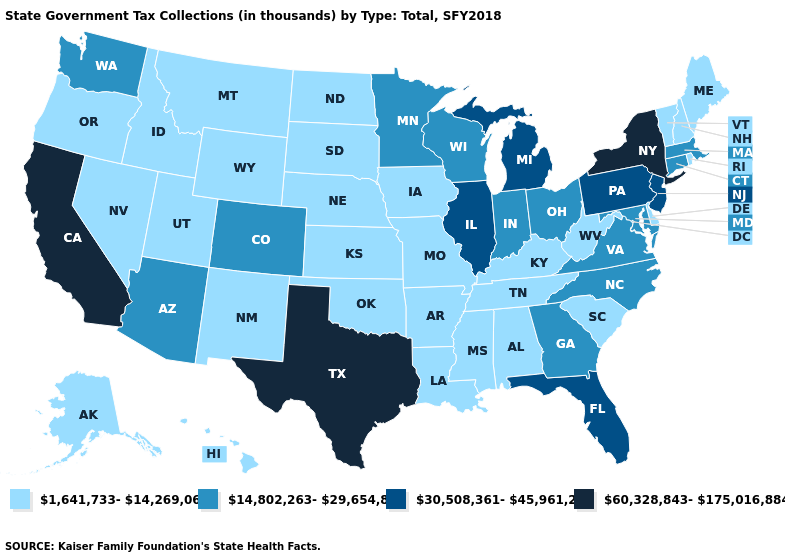Does Texas have the same value as New York?
Write a very short answer. Yes. Name the states that have a value in the range 14,802,263-29,654,803?
Write a very short answer. Arizona, Colorado, Connecticut, Georgia, Indiana, Maryland, Massachusetts, Minnesota, North Carolina, Ohio, Virginia, Washington, Wisconsin. Does Wisconsin have a lower value than Florida?
Concise answer only. Yes. Which states have the lowest value in the USA?
Short answer required. Alabama, Alaska, Arkansas, Delaware, Hawaii, Idaho, Iowa, Kansas, Kentucky, Louisiana, Maine, Mississippi, Missouri, Montana, Nebraska, Nevada, New Hampshire, New Mexico, North Dakota, Oklahoma, Oregon, Rhode Island, South Carolina, South Dakota, Tennessee, Utah, Vermont, West Virginia, Wyoming. Name the states that have a value in the range 30,508,361-45,961,204?
Write a very short answer. Florida, Illinois, Michigan, New Jersey, Pennsylvania. Does the map have missing data?
Write a very short answer. No. Name the states that have a value in the range 14,802,263-29,654,803?
Quick response, please. Arizona, Colorado, Connecticut, Georgia, Indiana, Maryland, Massachusetts, Minnesota, North Carolina, Ohio, Virginia, Washington, Wisconsin. Name the states that have a value in the range 30,508,361-45,961,204?
Give a very brief answer. Florida, Illinois, Michigan, New Jersey, Pennsylvania. How many symbols are there in the legend?
Short answer required. 4. What is the highest value in states that border Georgia?
Quick response, please. 30,508,361-45,961,204. What is the value of Connecticut?
Short answer required. 14,802,263-29,654,803. Does the map have missing data?
Be succinct. No. What is the value of Mississippi?
Quick response, please. 1,641,733-14,269,061. Does the first symbol in the legend represent the smallest category?
Quick response, please. Yes. Name the states that have a value in the range 14,802,263-29,654,803?
Keep it brief. Arizona, Colorado, Connecticut, Georgia, Indiana, Maryland, Massachusetts, Minnesota, North Carolina, Ohio, Virginia, Washington, Wisconsin. 